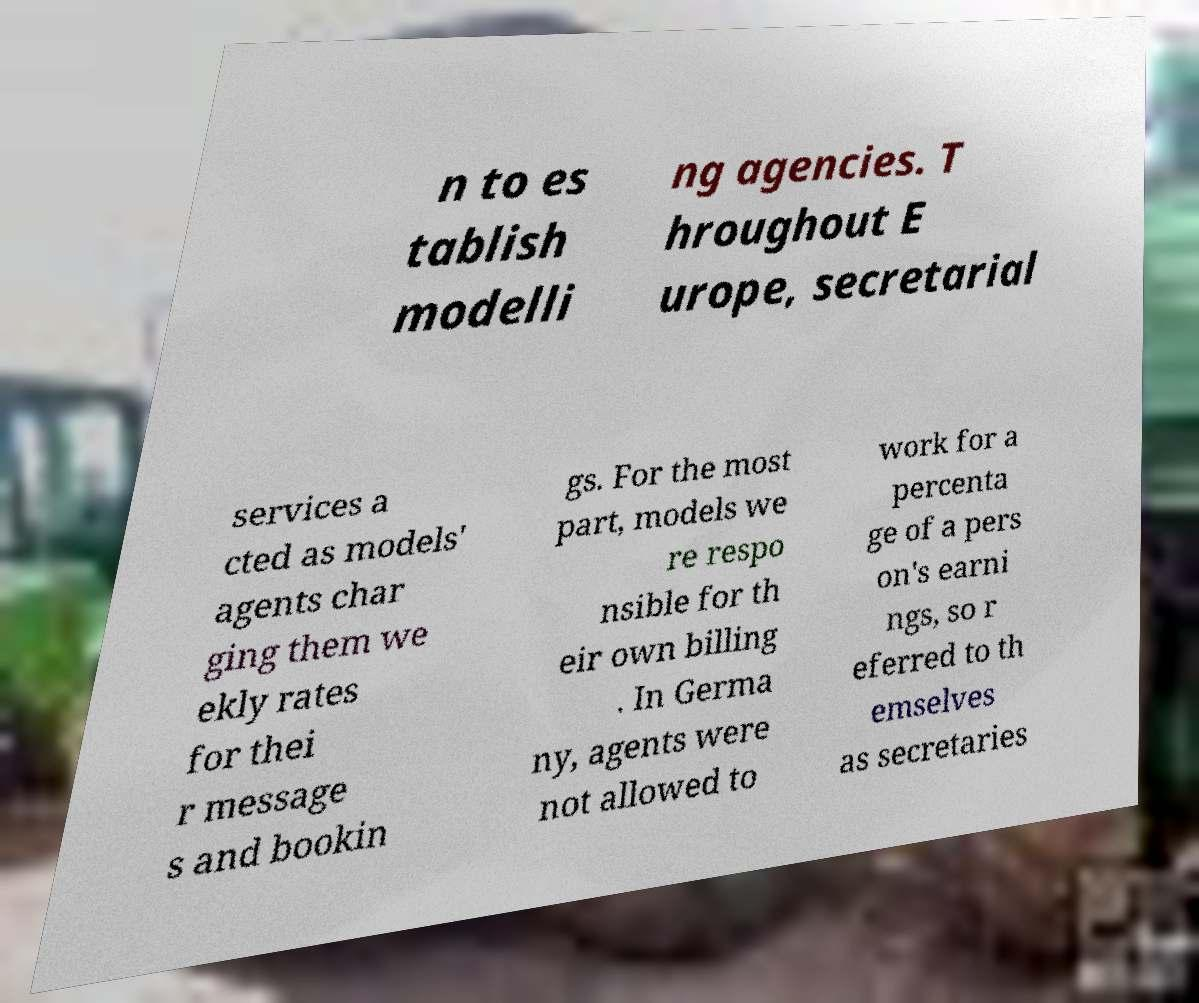I need the written content from this picture converted into text. Can you do that? n to es tablish modelli ng agencies. T hroughout E urope, secretarial services a cted as models' agents char ging them we ekly rates for thei r message s and bookin gs. For the most part, models we re respo nsible for th eir own billing . In Germa ny, agents were not allowed to work for a percenta ge of a pers on's earni ngs, so r eferred to th emselves as secretaries 